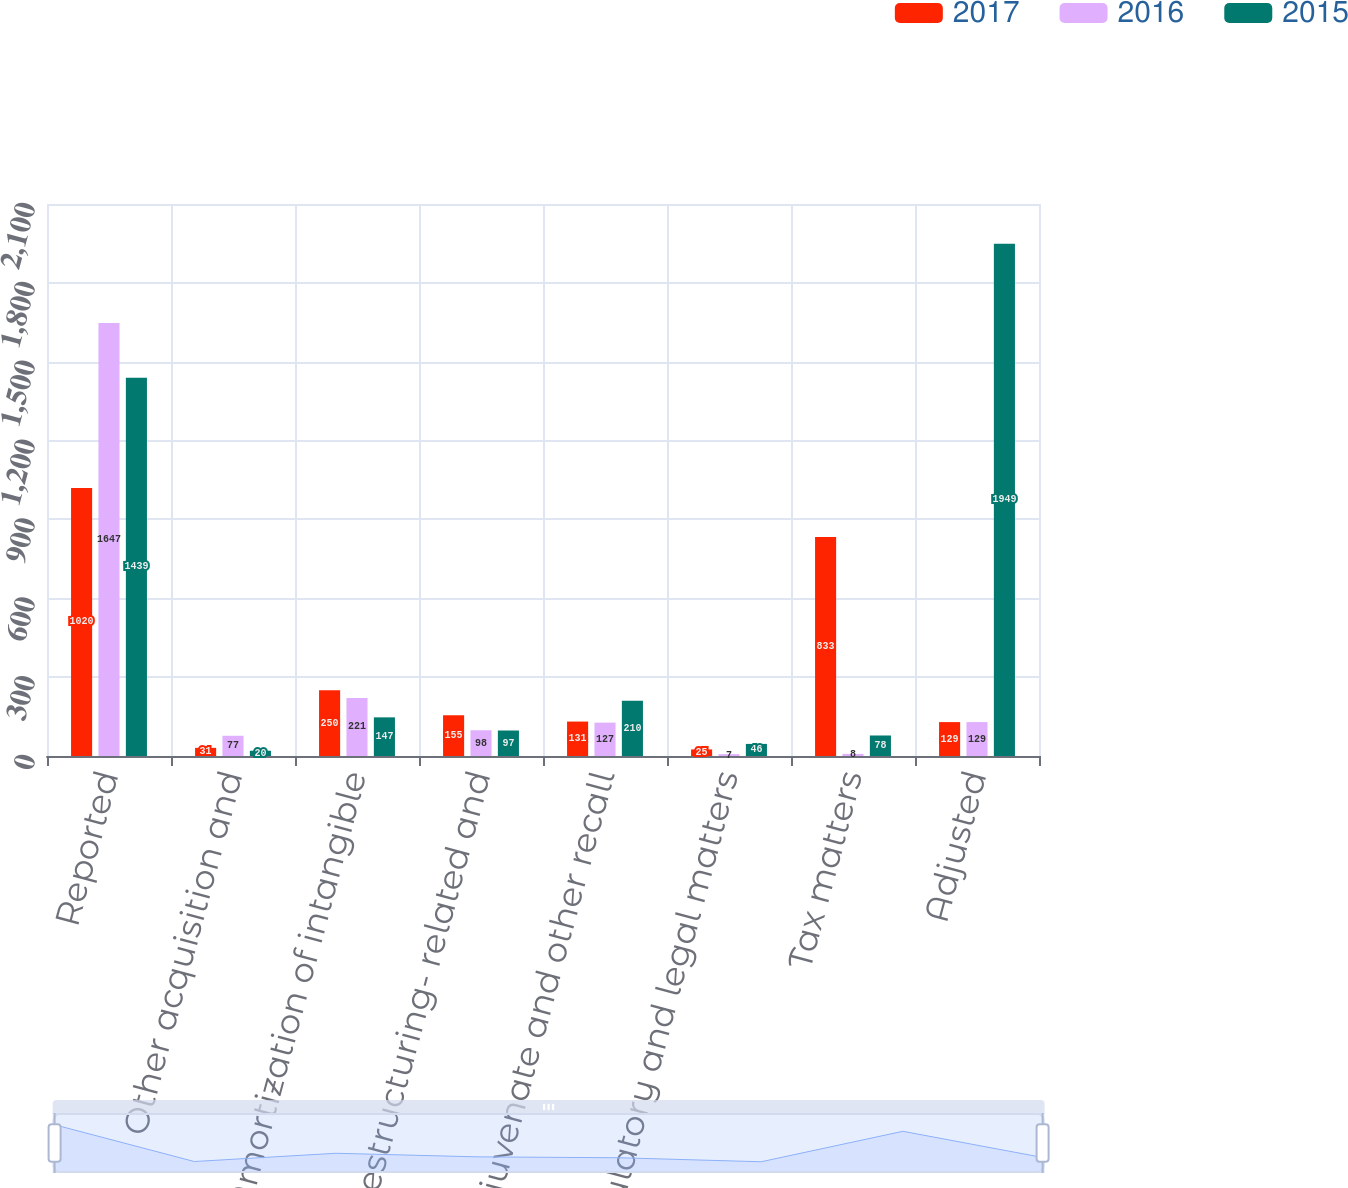Convert chart to OTSL. <chart><loc_0><loc_0><loc_500><loc_500><stacked_bar_chart><ecel><fcel>Reported<fcel>Other acquisition and<fcel>Amortization of intangible<fcel>Restructuring- related and<fcel>Rejuvenate and other recall<fcel>Regulatory and legal matters<fcel>Tax matters<fcel>Adjusted<nl><fcel>2017<fcel>1020<fcel>31<fcel>250<fcel>155<fcel>131<fcel>25<fcel>833<fcel>129<nl><fcel>2016<fcel>1647<fcel>77<fcel>221<fcel>98<fcel>127<fcel>7<fcel>8<fcel>129<nl><fcel>2015<fcel>1439<fcel>20<fcel>147<fcel>97<fcel>210<fcel>46<fcel>78<fcel>1949<nl></chart> 